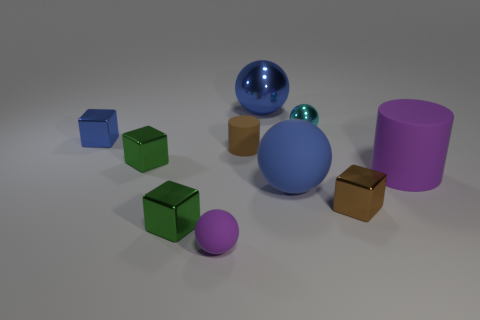Subtract all tiny cyan shiny balls. How many balls are left? 3 Subtract all blue cubes. How many cubes are left? 3 Subtract 3 balls. How many balls are left? 1 Subtract all blue cylinders. Subtract all gray blocks. How many cylinders are left? 2 Subtract all blue spheres. How many blue blocks are left? 1 Subtract all shiny objects. Subtract all purple cylinders. How many objects are left? 3 Add 7 blue cubes. How many blue cubes are left? 8 Add 9 brown matte cylinders. How many brown matte cylinders exist? 10 Subtract 1 blue cubes. How many objects are left? 9 Subtract all balls. How many objects are left? 6 